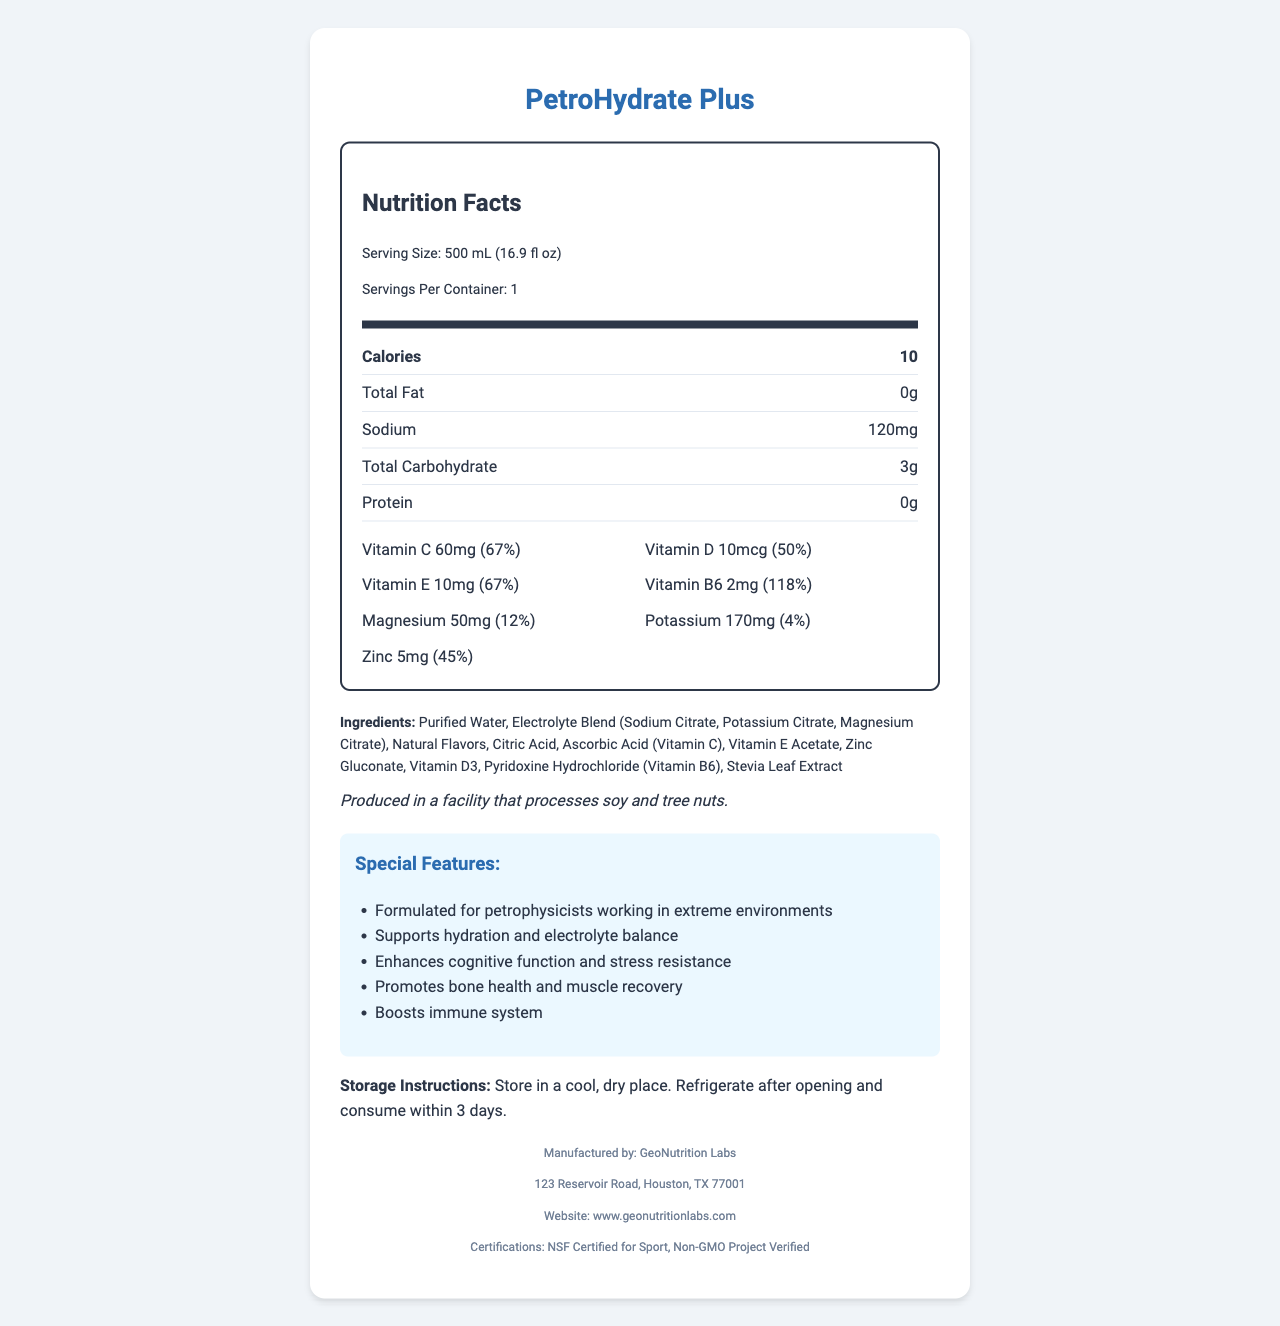what is the serving size? The serving size is stated in the nutrition facts section as 500 mL (16.9 fl oz).
Answer: 500 mL (16.9 fl oz) how much sodium is in each serving? The nutrition facts section lists 120mg of sodium per serving.
Answer: 120mg what is the calorie count per serving? The calories per serving are indicated as 10 in the nutrition facts section.
Answer: 10 calories list three main ingredients found in PetroHydrate Plus. The ingredient list mentions these as the first three components.
Answer: Purified Water, Electrolyte Blend (Sodium Citrate, Potassium Citrate, Magnesium Citrate), Natural Flavors how are you supposed to store PetroHydrate Plus after opening? The storage instructions specify to refrigerate after opening and consume within 3 days.
Answer: Refrigerate and consume within 3 days what percentage of daily value of Vitamin B6 does PetroHydrate Plus provide? A. 67% B. 50% C. 118% D. 45% The nutrition label indicates that Vitamin B6 provides 118% of the daily value.
Answer: C. 118% which vitamins and minerals listed have the highest percentage of daily value? A. Vitamin C B. Vitamin E C. Vitamin B6 D. Zinc Vitamin B6 has the highest daily value percentage at 118%.
Answer: C. Vitamin B6 is PetroHydrate Plus non-GMO? The certifications section mentions that the product is Non-GMO Project Verified.
Answer: Yes does PetroHydrate Plus contain any allergens? The allergen information section states this.
Answer: Produced in a facility that processes soy and tree nuts describe the purpose of PetroHydrate Plus. The special features section outlines the purpose and benefits of PetroHydrate Plus.
Answer: Formulated for petrophysicists working in extreme environments, supports hydration and electrolyte balance, enhances cognitive function and stress resistance, promotes bone health and muscle recovery, boosts immune system what is the manufacturer's contact information? The details for contacting the manufacturer are not provided beyond the address and website.
Answer: Not enough information what are the special features of PetroHydrate Plus? The special features section lists these points.
Answer: Formulated for petrophysicists working in extreme environments, supports hydration and electrolyte balance, enhances cognitive function and stress resistance, promotes bone health and muscle recovery, boosts immune system what certifications does PetroHydrate Plus have? The certifications section includes NSF Certified for Sport and Non-GMO Project Verified.
Answer: NSF Certified for Sport, Non-GMO Project Verified explain why PetroHydrate Plus could be beneficial for a petrophysicist working in extreme environments. Due to the demanding nature of extreme environments, maintaining strong cognitive function, hydration, electrolyte balance, and physical recovery is crucial. The vitamins and minerals in PetroHydrate Plus target these needs, supporting overall health and work efficiency for petrophysicists.
Answer: Enhances cognitive function and stress resistance, supports hydration and electrolyte balance, promotes bone health and muscle recovery, boosts immune system 